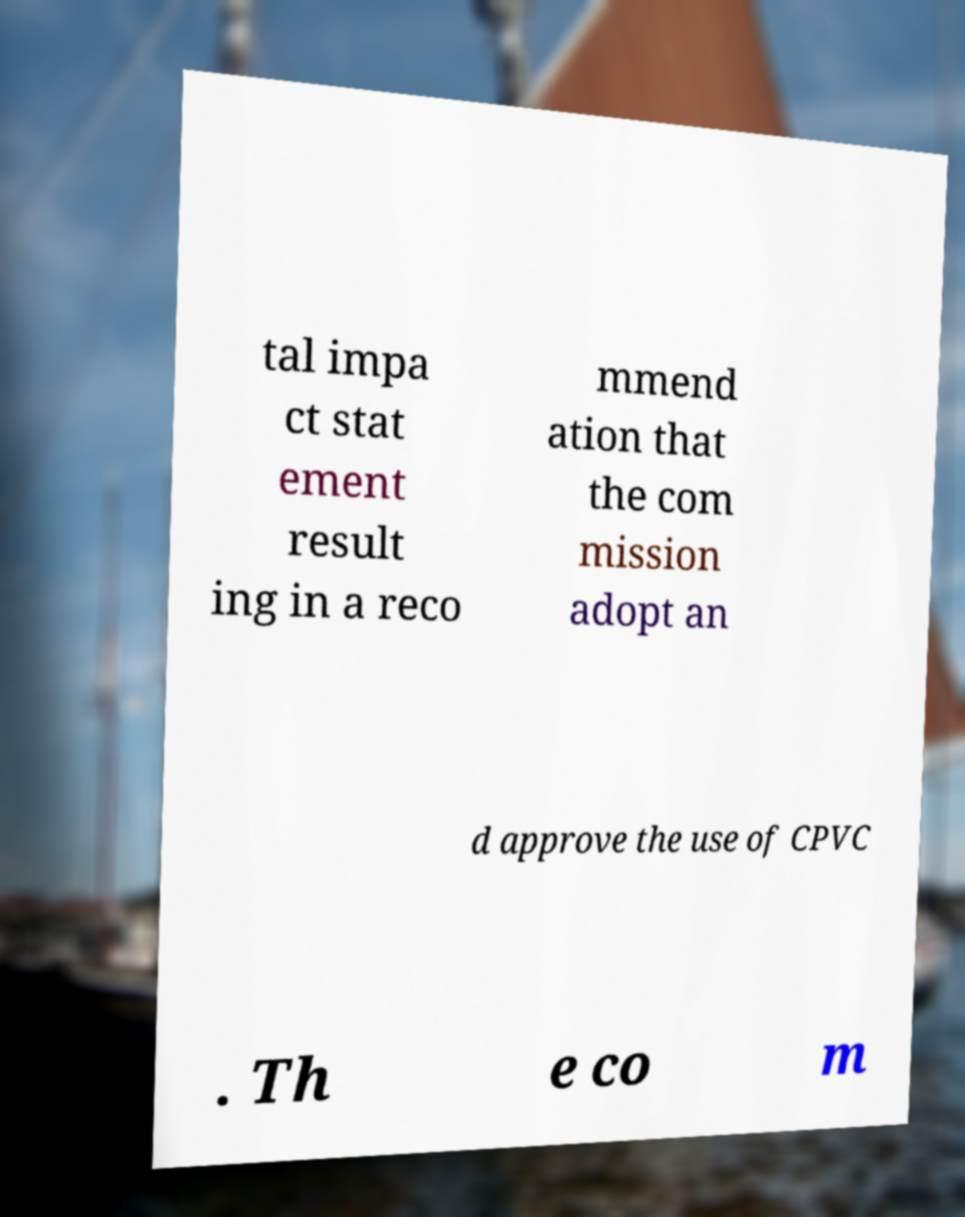Can you read and provide the text displayed in the image?This photo seems to have some interesting text. Can you extract and type it out for me? tal impa ct stat ement result ing in a reco mmend ation that the com mission adopt an d approve the use of CPVC . Th e co m 